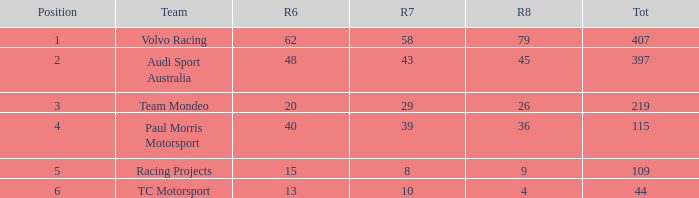Could you parse the entire table? {'header': ['Position', 'Team', 'R6', 'R7', 'R8', 'Tot'], 'rows': [['1', 'Volvo Racing', '62', '58', '79', '407'], ['2', 'Audi Sport Australia', '48', '43', '45', '397'], ['3', 'Team Mondeo', '20', '29', '26', '219'], ['4', 'Paul Morris Motorsport', '40', '39', '36', '115'], ['5', 'Racing Projects', '15', '8', '9', '109'], ['6', 'TC Motorsport', '13', '10', '4', '44']]} What is the average value for Rd 8 in a position less than 2 for Audi Sport Australia? None. 